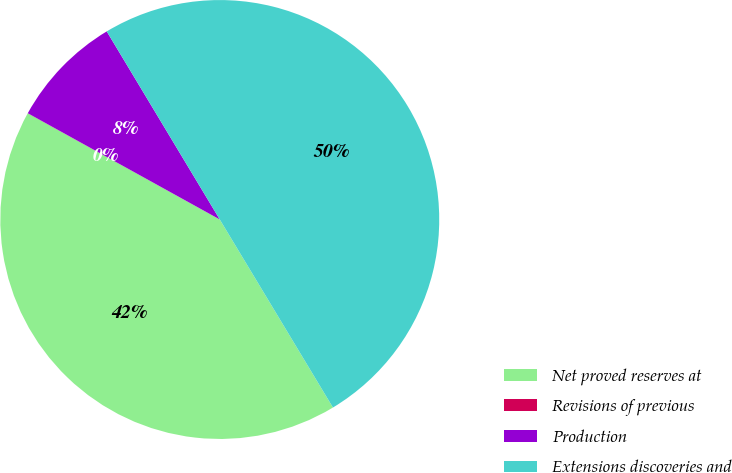<chart> <loc_0><loc_0><loc_500><loc_500><pie_chart><fcel>Net proved reserves at<fcel>Revisions of previous<fcel>Production<fcel>Extensions discoveries and<nl><fcel>41.66%<fcel>0.01%<fcel>8.34%<fcel>49.99%<nl></chart> 